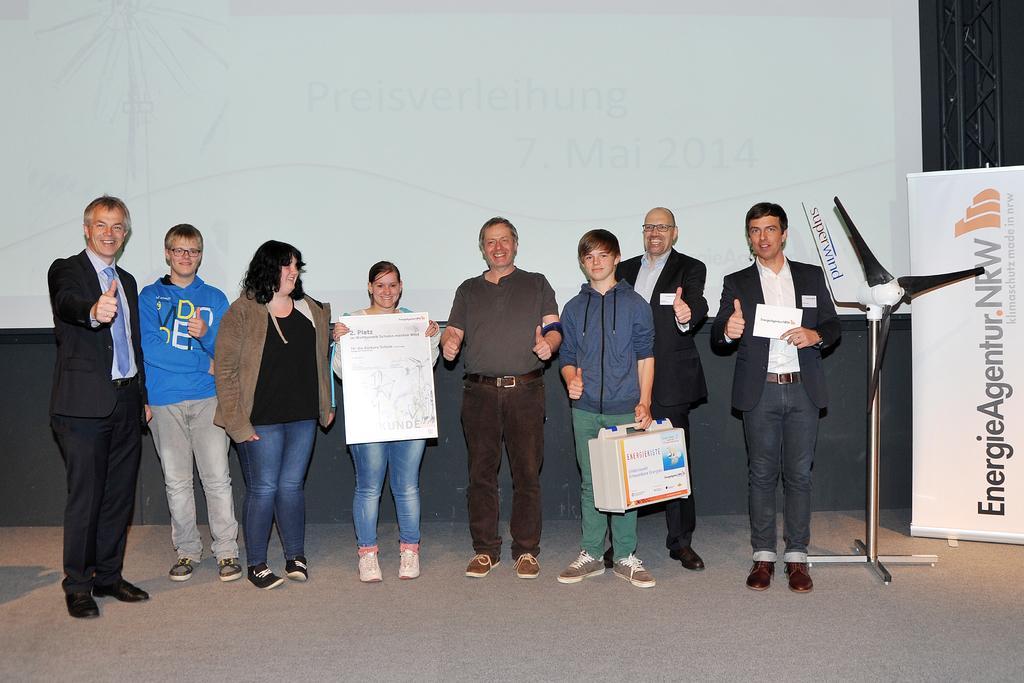Could you give a brief overview of what you see in this image? This picture describes about group of people, they are standing, beside to them we can see a fan, metal rods and a hoarding, in the background we can find a projector screen. 